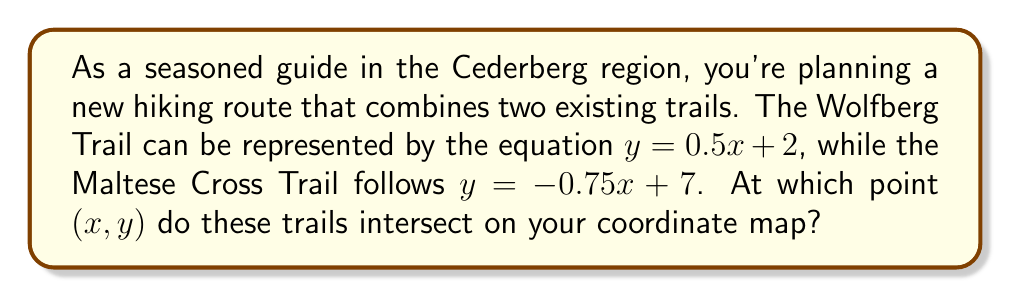Help me with this question. To find the intersection point of the two trails, we need to solve the system of linear equations:

$$\begin{cases}
y = 0.5x + 2 \quad \text{(Wolfberg Trail)} \\
y = -0.75x + 7 \quad \text{(Maltese Cross Trail)}
\end{cases}$$

1) At the intersection point, the y-coordinates are equal. So, we can set the right sides of the equations equal to each other:

   $0.5x + 2 = -0.75x + 7$

2) Solve for x:
   $0.5x + 0.75x = 7 - 2$
   $1.25x = 5$
   $x = 5 \div 1.25 = 4$

3) Now that we know the x-coordinate of the intersection point, we can substitute it into either of the original equations to find the y-coordinate. Let's use the Wolfberg Trail equation:

   $y = 0.5(4) + 2$
   $y = 2 + 2 = 4$

Therefore, the trails intersect at the point (4, 4) on the coordinate map.
Answer: (4, 4) 